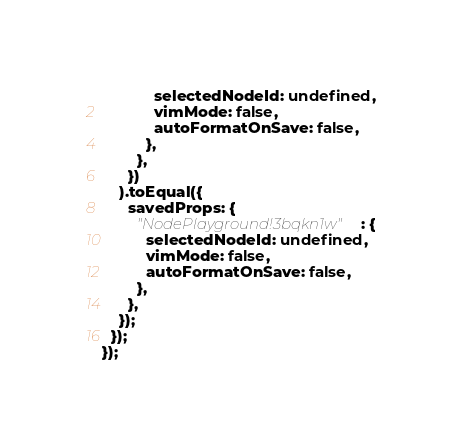Convert code to text. <code><loc_0><loc_0><loc_500><loc_500><_JavaScript_>            selectedNodeId: undefined,
            vimMode: false,
            autoFormatOnSave: false,
          },
        },
      })
    ).toEqual({
      savedProps: {
        "NodePlayground!3bqkn1w": {
          selectedNodeId: undefined,
          vimMode: false,
          autoFormatOnSave: false,
        },
      },
    });
  });
});
</code> 